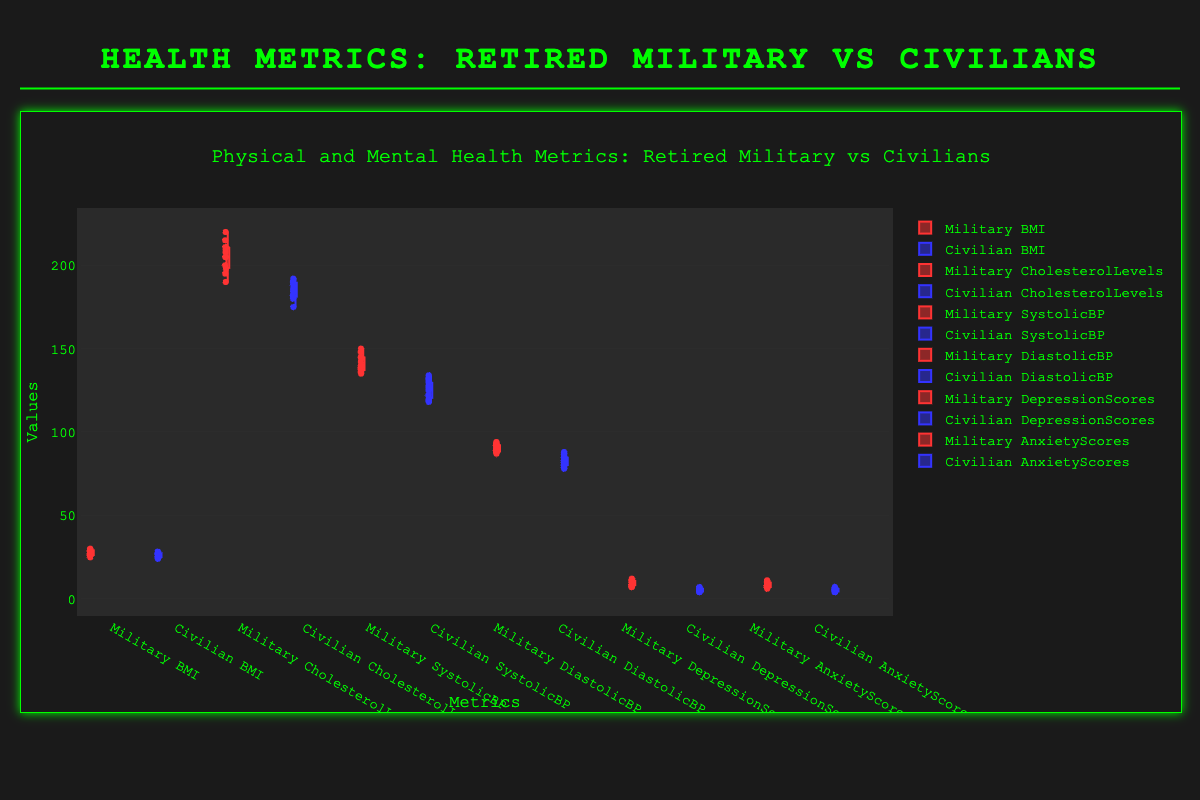What metric is being compared between retired military personnel and civilians in the title? The title indicates that Physical and Mental Health Metrics are being compared
Answer: Physical and Mental Health Metrics Which group has the higher median BMI? Look at the median line in the box for BMI in both groups. The median for Retired Military seems higher than that for Civilians
Answer: Retired Military How does the range of cholesterol levels compare between retired military personnel and civilians? Range is the difference between the maximum and minimum values in the data. The box plot shows that the Retired Military group has a wider range of cholesterol levels compared to Civilians
Answer: Retired Military has a wider range Which group exhibits higher depression scores on average? By observing the box plots for depression scores, the median and distribution indicate that Retired Military has higher values on average compared to Civilians
Answer: Retired Military Are there any overlapping values in the anxiety scores between the two groups? Check the box plots for Anxiety Scores and observe the data points' spread. There is an overlap between the anxiety scores of Retired Military and Civilians
Answer: Yes What is the approximate interquartile range (IQR) for diastolic blood pressure in civilians? The IQR is the difference between the third quartile (Q3) and first quartile (Q1). From the box plot for Civilians’ DiastolicBP, estimate Q3 and Q1 and calculate Q3-Q1
Answer: Around 5 (Q3=84, Q1=79) Which group shows greater variability in systolic blood pressure, and how can you tell? Variability can be assessed by the spread of the whiskers and box. The Retired Military group shows a larger spread in the box plot for SystolicBP, indicating greater variability
Answer: Retired Military Do retired military personnel generally have higher cholesterol levels compared to civilians? By comparing the median lines and the distribution in the CholesterolLevels box plots, it's evident that Retired Military personnel generally have higher cholesterol levels
Answer: Yes Which group has lower overall scores in mental health metrics like depression and anxiety? Observe both DepressionScores and AnxietyScores box plots. Civilians consistently show lower overall scores in both metrics compared to Retired Military
Answer: Civilians For retired military personnel, which metric shows the highest median value: BMI, Cholesterol Levels, SystolicBP, or DiastolicBP? Compare median lines across all Retired Military metrics. Cholesterol Levels show the highest median value
Answer: Cholesterol Levels 